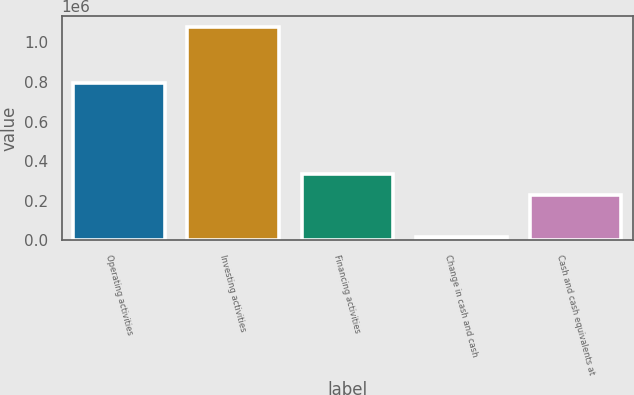<chart> <loc_0><loc_0><loc_500><loc_500><bar_chart><fcel>Operating activities<fcel>Investing activities<fcel>Financing activities<fcel>Change in cash and cash<fcel>Cash and cash equivalents at<nl><fcel>794990<fcel>1.07973e+06<fcel>337136<fcel>18881<fcel>231051<nl></chart> 